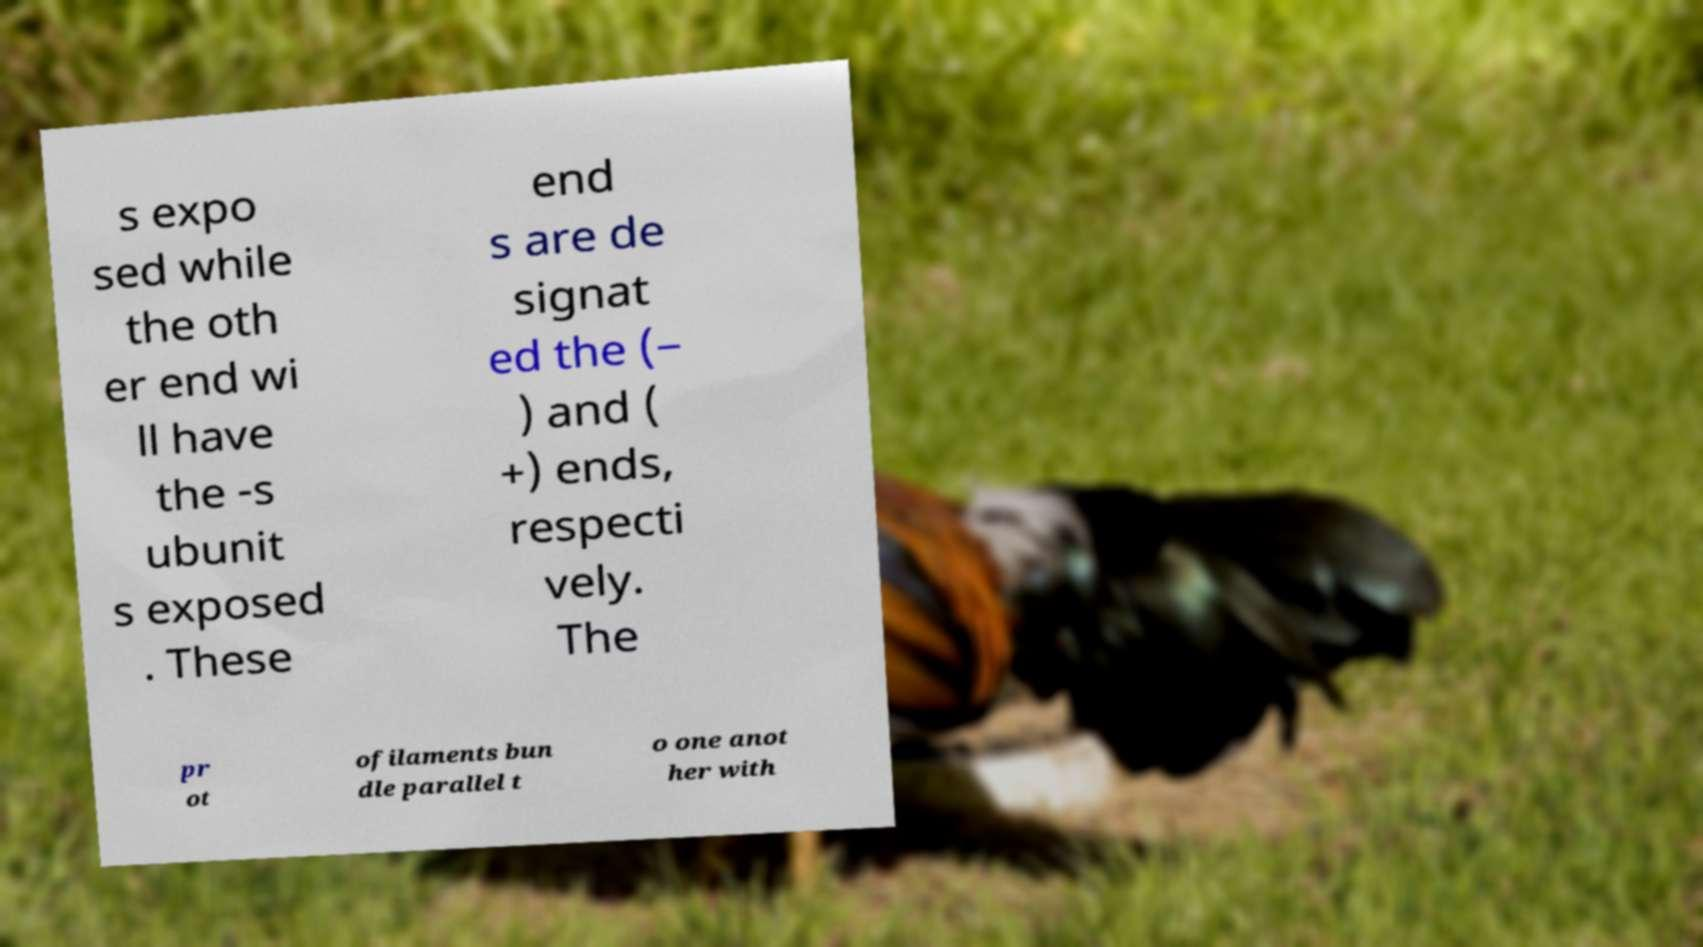There's text embedded in this image that I need extracted. Can you transcribe it verbatim? s expo sed while the oth er end wi ll have the -s ubunit s exposed . These end s are de signat ed the (− ) and ( +) ends, respecti vely. The pr ot ofilaments bun dle parallel t o one anot her with 